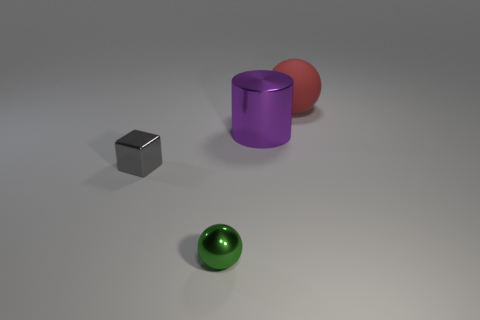Add 3 big metal objects. How many objects exist? 7 Subtract all blocks. How many objects are left? 3 Subtract 0 gray spheres. How many objects are left? 4 Subtract all yellow blocks. Subtract all gray things. How many objects are left? 3 Add 3 big red things. How many big red things are left? 4 Add 3 metal cubes. How many metal cubes exist? 4 